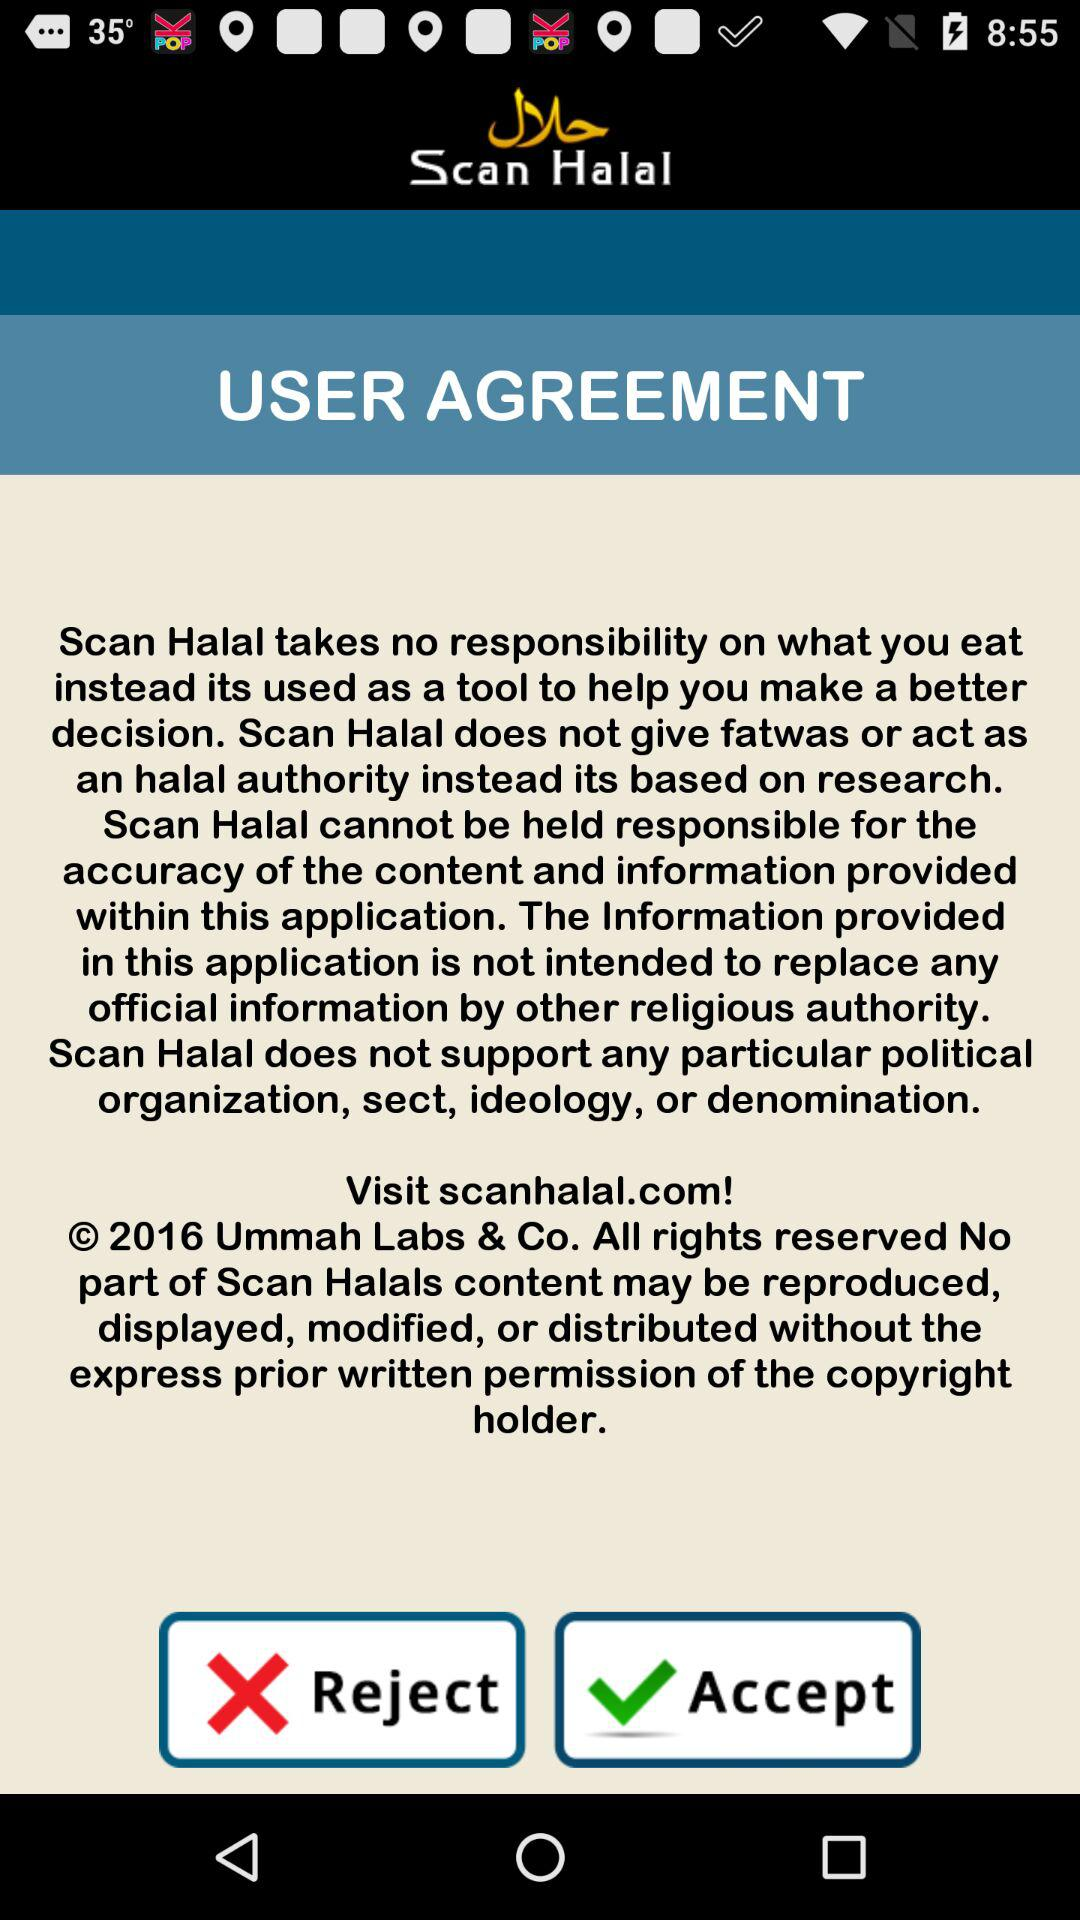Define the official website of application?
When the provided information is insufficient, respond with <no answer>. <no answer> 